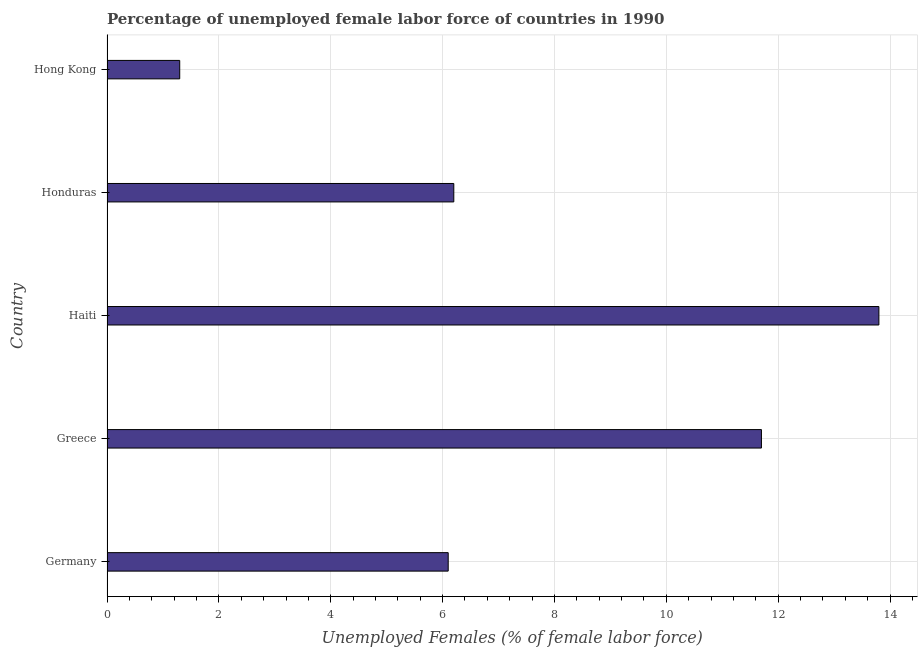Does the graph contain any zero values?
Your answer should be very brief. No. What is the title of the graph?
Your answer should be very brief. Percentage of unemployed female labor force of countries in 1990. What is the label or title of the X-axis?
Make the answer very short. Unemployed Females (% of female labor force). What is the label or title of the Y-axis?
Your answer should be very brief. Country. What is the total unemployed female labour force in Haiti?
Your response must be concise. 13.8. Across all countries, what is the maximum total unemployed female labour force?
Your answer should be compact. 13.8. Across all countries, what is the minimum total unemployed female labour force?
Keep it short and to the point. 1.3. In which country was the total unemployed female labour force maximum?
Offer a terse response. Haiti. In which country was the total unemployed female labour force minimum?
Your answer should be very brief. Hong Kong. What is the sum of the total unemployed female labour force?
Make the answer very short. 39.1. What is the difference between the total unemployed female labour force in Greece and Hong Kong?
Your answer should be compact. 10.4. What is the average total unemployed female labour force per country?
Ensure brevity in your answer.  7.82. What is the median total unemployed female labour force?
Offer a very short reply. 6.2. In how many countries, is the total unemployed female labour force greater than 3.2 %?
Offer a terse response. 4. What is the ratio of the total unemployed female labour force in Honduras to that in Hong Kong?
Provide a short and direct response. 4.77. What is the difference between the highest and the second highest total unemployed female labour force?
Offer a very short reply. 2.1. Is the sum of the total unemployed female labour force in Germany and Haiti greater than the maximum total unemployed female labour force across all countries?
Your answer should be compact. Yes. In how many countries, is the total unemployed female labour force greater than the average total unemployed female labour force taken over all countries?
Offer a terse response. 2. How many bars are there?
Offer a very short reply. 5. What is the difference between two consecutive major ticks on the X-axis?
Your answer should be very brief. 2. What is the Unemployed Females (% of female labor force) in Germany?
Keep it short and to the point. 6.1. What is the Unemployed Females (% of female labor force) in Greece?
Give a very brief answer. 11.7. What is the Unemployed Females (% of female labor force) in Haiti?
Offer a terse response. 13.8. What is the Unemployed Females (% of female labor force) of Honduras?
Your answer should be compact. 6.2. What is the Unemployed Females (% of female labor force) in Hong Kong?
Your answer should be compact. 1.3. What is the difference between the Unemployed Females (% of female labor force) in Germany and Greece?
Provide a succinct answer. -5.6. What is the difference between the Unemployed Females (% of female labor force) in Germany and Honduras?
Your answer should be compact. -0.1. What is the difference between the Unemployed Females (% of female labor force) in Germany and Hong Kong?
Provide a short and direct response. 4.8. What is the difference between the Unemployed Females (% of female labor force) in Greece and Honduras?
Offer a very short reply. 5.5. What is the difference between the Unemployed Females (% of female labor force) in Haiti and Honduras?
Your answer should be very brief. 7.6. What is the ratio of the Unemployed Females (% of female labor force) in Germany to that in Greece?
Your answer should be very brief. 0.52. What is the ratio of the Unemployed Females (% of female labor force) in Germany to that in Haiti?
Give a very brief answer. 0.44. What is the ratio of the Unemployed Females (% of female labor force) in Germany to that in Hong Kong?
Keep it short and to the point. 4.69. What is the ratio of the Unemployed Females (% of female labor force) in Greece to that in Haiti?
Offer a terse response. 0.85. What is the ratio of the Unemployed Females (% of female labor force) in Greece to that in Honduras?
Make the answer very short. 1.89. What is the ratio of the Unemployed Females (% of female labor force) in Greece to that in Hong Kong?
Make the answer very short. 9. What is the ratio of the Unemployed Females (% of female labor force) in Haiti to that in Honduras?
Provide a short and direct response. 2.23. What is the ratio of the Unemployed Females (% of female labor force) in Haiti to that in Hong Kong?
Keep it short and to the point. 10.62. What is the ratio of the Unemployed Females (% of female labor force) in Honduras to that in Hong Kong?
Your response must be concise. 4.77. 